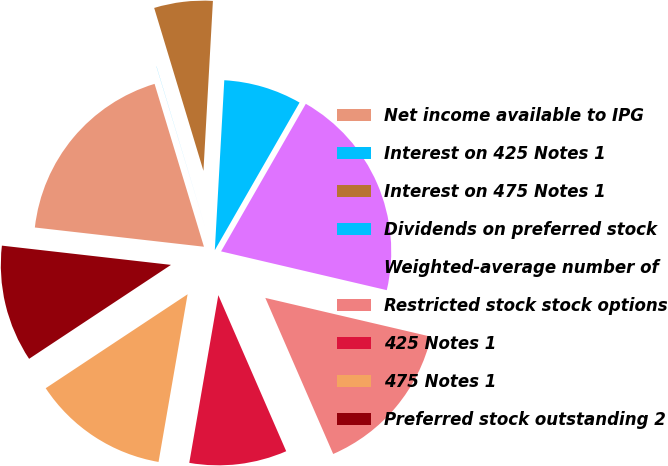<chart> <loc_0><loc_0><loc_500><loc_500><pie_chart><fcel>Net income available to IPG<fcel>Interest on 425 Notes 1<fcel>Interest on 475 Notes 1<fcel>Dividends on preferred stock<fcel>Weighted-average number of<fcel>Restricted stock stock options<fcel>425 Notes 1<fcel>475 Notes 1<fcel>Preferred stock outstanding 2<nl><fcel>18.51%<fcel>0.01%<fcel>5.56%<fcel>7.41%<fcel>20.36%<fcel>14.81%<fcel>9.26%<fcel>12.96%<fcel>11.11%<nl></chart> 